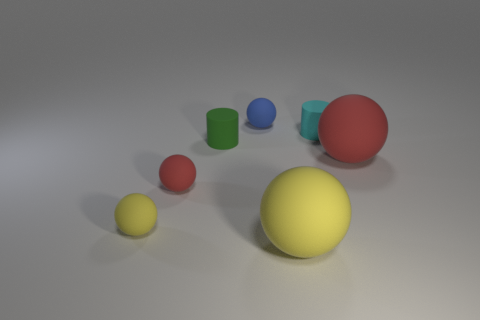There is a tiny cylinder to the left of the big sphere in front of the yellow object that is to the left of the tiny red rubber thing; what color is it?
Offer a very short reply. Green. Does the small blue rubber thing have the same shape as the red rubber object on the left side of the blue rubber ball?
Ensure brevity in your answer.  Yes. There is a small thing that is in front of the small blue sphere and to the right of the tiny green cylinder; what color is it?
Ensure brevity in your answer.  Cyan. Is there another thing that has the same shape as the cyan rubber object?
Make the answer very short. Yes. There is a small rubber sphere that is right of the small green cylinder; is there a green rubber cylinder that is in front of it?
Give a very brief answer. Yes. How many objects are either yellow matte spheres that are on the left side of the blue matte ball or small rubber objects that are in front of the tiny cyan matte thing?
Offer a terse response. 3. What number of things are either large red metallic spheres or tiny rubber spheres that are behind the large red sphere?
Your answer should be very brief. 1. What size is the ball to the right of the matte thing that is in front of the yellow ball that is left of the tiny green thing?
Provide a short and direct response. Large. Are there any green cylinders of the same size as the blue rubber ball?
Your answer should be compact. Yes. Do the red sphere right of the cyan matte cylinder and the tiny red rubber ball have the same size?
Make the answer very short. No. 